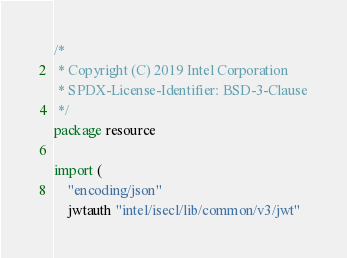<code> <loc_0><loc_0><loc_500><loc_500><_Go_>/*
 * Copyright (C) 2019 Intel Corporation
 * SPDX-License-Identifier: BSD-3-Clause
 */
package resource

import (
	"encoding/json"
	jwtauth "intel/isecl/lib/common/v3/jwt"</code> 